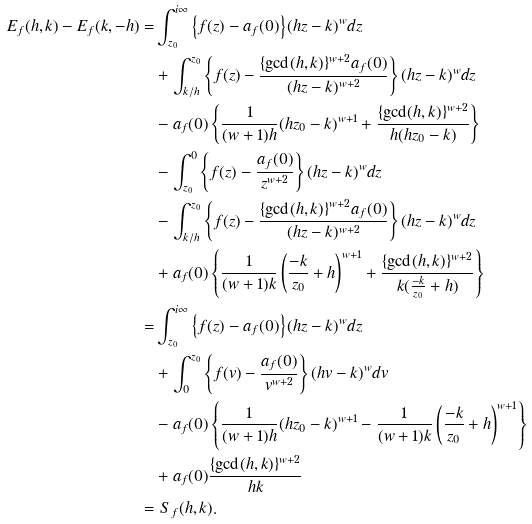Convert formula to latex. <formula><loc_0><loc_0><loc_500><loc_500>E _ { f } ( h , k ) - E _ { f } ( k , - h ) = & \int _ { z _ { 0 } } ^ { i \infty } \left \{ f ( z ) - a _ { f } ( 0 ) \right \} ( h z - k ) ^ { w } d z \\ & + \int _ { k / h } ^ { z _ { 0 } } \left \{ f ( z ) - \frac { \{ \gcd ( h , k ) \} ^ { w + 2 } a _ { f } ( 0 ) } { ( h z - k ) ^ { w + 2 } } \right \} ( h z - k ) ^ { w } d z \\ & - a _ { f } ( 0 ) \left \{ \frac { 1 } { ( w + 1 ) h } ( h z _ { 0 } - k ) ^ { w + 1 } + \frac { \{ \gcd ( h , k ) \} ^ { w + 2 } } { h ( h z _ { 0 } - k ) } \right \} \\ & - \int _ { z _ { 0 } } ^ { 0 } \left \{ f ( z ) - \frac { a _ { f } ( 0 ) } { z ^ { w + 2 } } \right \} ( h z - k ) ^ { w } d z \\ & - \int _ { k / h } ^ { z _ { 0 } } \left \{ f ( z ) - \frac { \{ \gcd ( h , k ) \} ^ { w + 2 } a _ { f } ( 0 ) } { ( h z - k ) ^ { w + 2 } } \right \} ( h z - k ) ^ { w } d z \\ & + a _ { f } ( 0 ) \left \{ \frac { 1 } { ( w + 1 ) k } \left ( \frac { - k } { z _ { 0 } } + h \right ) ^ { w + 1 } + \frac { \{ \gcd ( h , k ) \} ^ { w + 2 } } { k ( \frac { - k } { z _ { 0 } } + h ) } \right \} \\ = & \int _ { z _ { 0 } } ^ { i \infty } \left \{ f ( z ) - a _ { f } ( 0 ) \right \} ( h z - k ) ^ { w } d z \\ & + \int _ { 0 } ^ { z _ { 0 } } \left \{ f ( v ) - \frac { a _ { f } ( 0 ) } { v ^ { w + 2 } } \right \} ( h v - k ) ^ { w } d v \\ & - a _ { f } ( 0 ) \left \{ \frac { 1 } { ( w + 1 ) h } ( h z _ { 0 } - k ) ^ { w + 1 } - \frac { 1 } { ( w + 1 ) k } \left ( \frac { - k } { z _ { 0 } } + h \right ) ^ { w + 1 } \right \} \\ & + a _ { f } ( 0 ) \frac { \{ \gcd ( h , k ) \} ^ { w + 2 } } { h k } \\ = & \ S _ { f } ( h , k ) .</formula> 